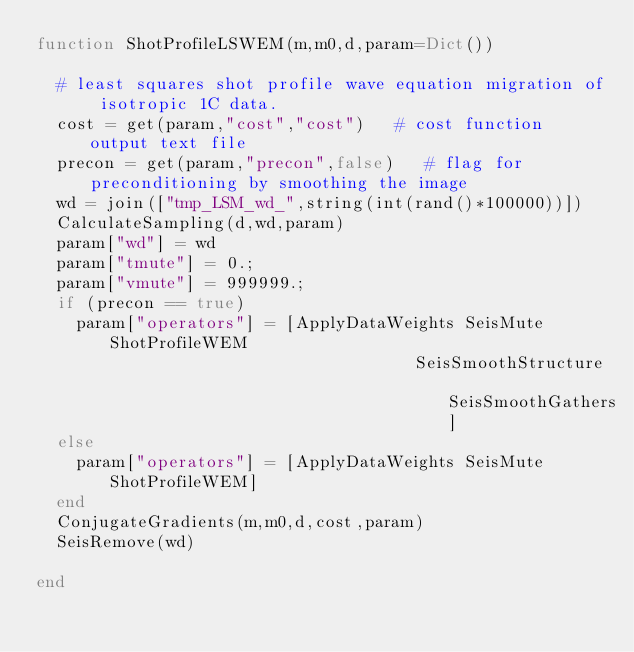<code> <loc_0><loc_0><loc_500><loc_500><_Julia_>function ShotProfileLSWEM(m,m0,d,param=Dict())

	# least squares shot profile wave equation migration of isotropic 1C data. 
	cost = get(param,"cost","cost")   # cost function output text file
	precon = get(param,"precon",false)   # flag for preconditioning by smoothing the image
	wd = join(["tmp_LSM_wd_",string(int(rand()*100000))])
	CalculateSampling(d,wd,param)
	param["wd"] = wd
	param["tmute"] = 0.;
	param["vmute"] = 999999.;
	if (precon == true)
		param["operators"] = [ApplyDataWeights SeisMute ShotProfileWEM
                                      SeisSmoothStructure SeisSmoothGathers]
	else
		param["operators"] = [ApplyDataWeights SeisMute ShotProfileWEM]
	end
	ConjugateGradients(m,m0,d,cost,param)
	SeisRemove(wd)

end
</code> 